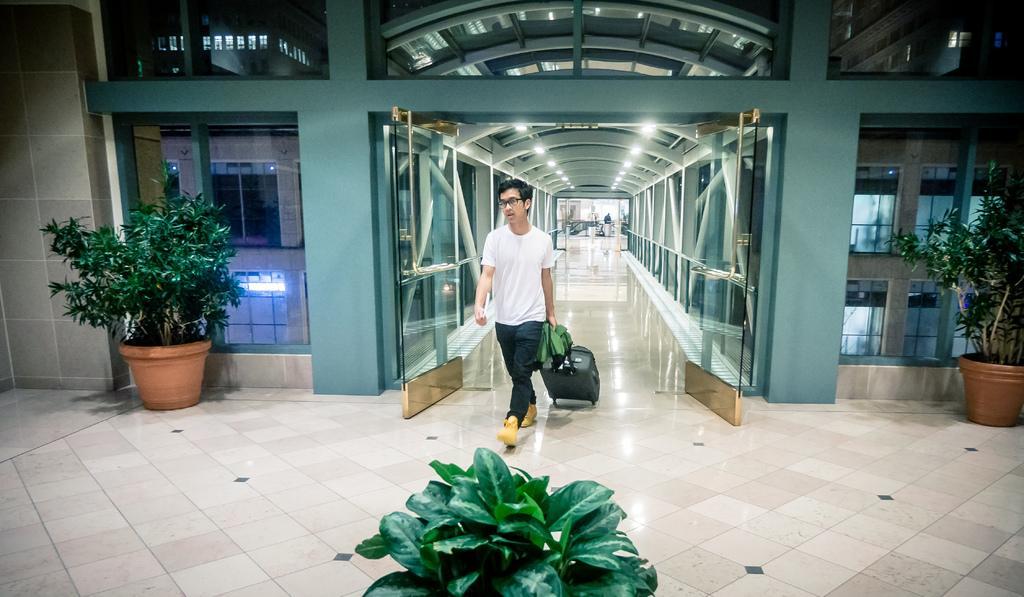In one or two sentences, can you explain what this image depicts? In this image a person walking with luggage on a floor, on either side of him there are plants, in the middle there is a plant, in the background there is a building on top there are lights. 